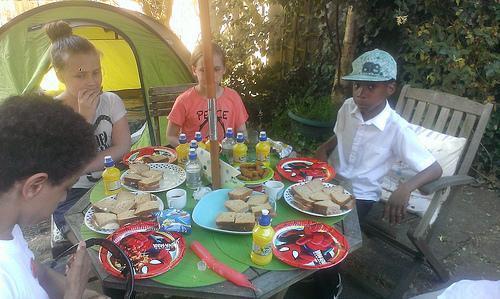How many children are in this photo?
Give a very brief answer. 4. 